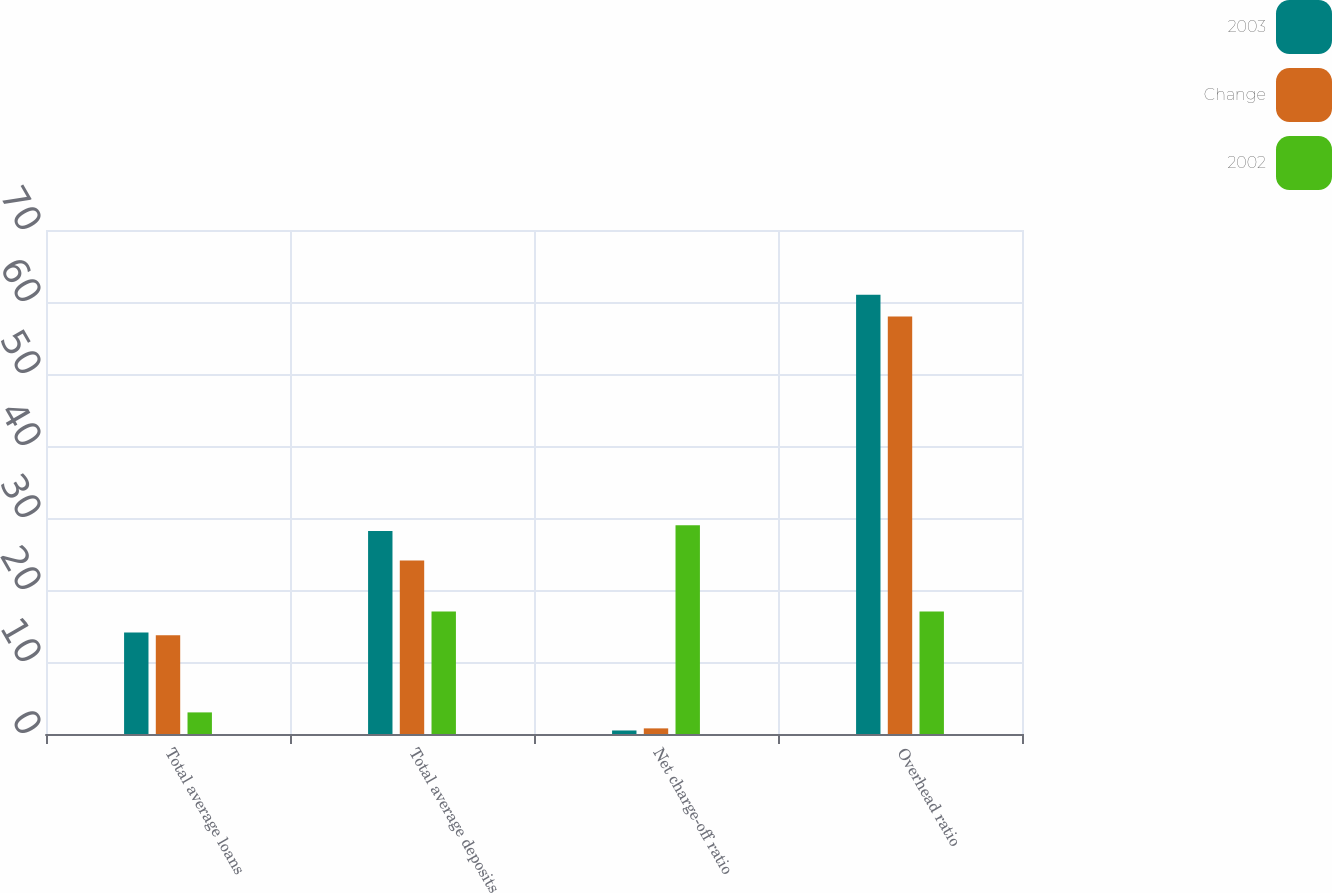Convert chart. <chart><loc_0><loc_0><loc_500><loc_500><stacked_bar_chart><ecel><fcel>Total average loans<fcel>Total average deposits<fcel>Net charge-off ratio<fcel>Overhead ratio<nl><fcel>2003<fcel>14.1<fcel>28.2<fcel>0.49<fcel>61<nl><fcel>Change<fcel>13.7<fcel>24.1<fcel>0.78<fcel>58<nl><fcel>2002<fcel>3<fcel>17<fcel>29<fcel>17<nl></chart> 